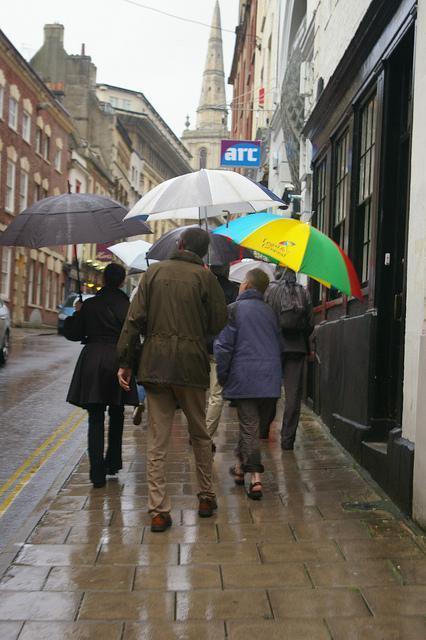How many people are there?
Give a very brief answer. 4. How many umbrellas are there?
Give a very brief answer. 3. How many arched windows are there to the left of the clock tower?
Give a very brief answer. 0. 